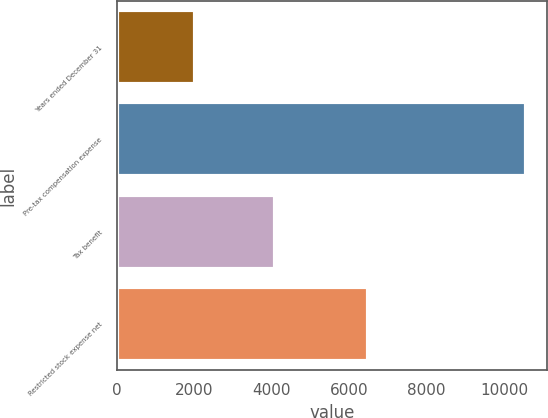Convert chart to OTSL. <chart><loc_0><loc_0><loc_500><loc_500><bar_chart><fcel>Years ended December 31<fcel>Pre-tax compensation expense<fcel>Tax benefit<fcel>Restricted stock expense net<nl><fcel>2014<fcel>10579<fcel>4094<fcel>6485<nl></chart> 